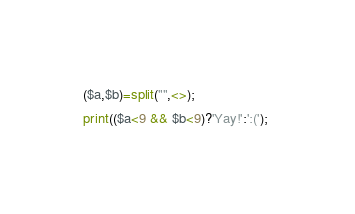Convert code to text. <code><loc_0><loc_0><loc_500><loc_500><_Perl_>($a,$b)=split("",<>);
print(($a<9 && $b<9)?'Yay!':':('); 
</code> 